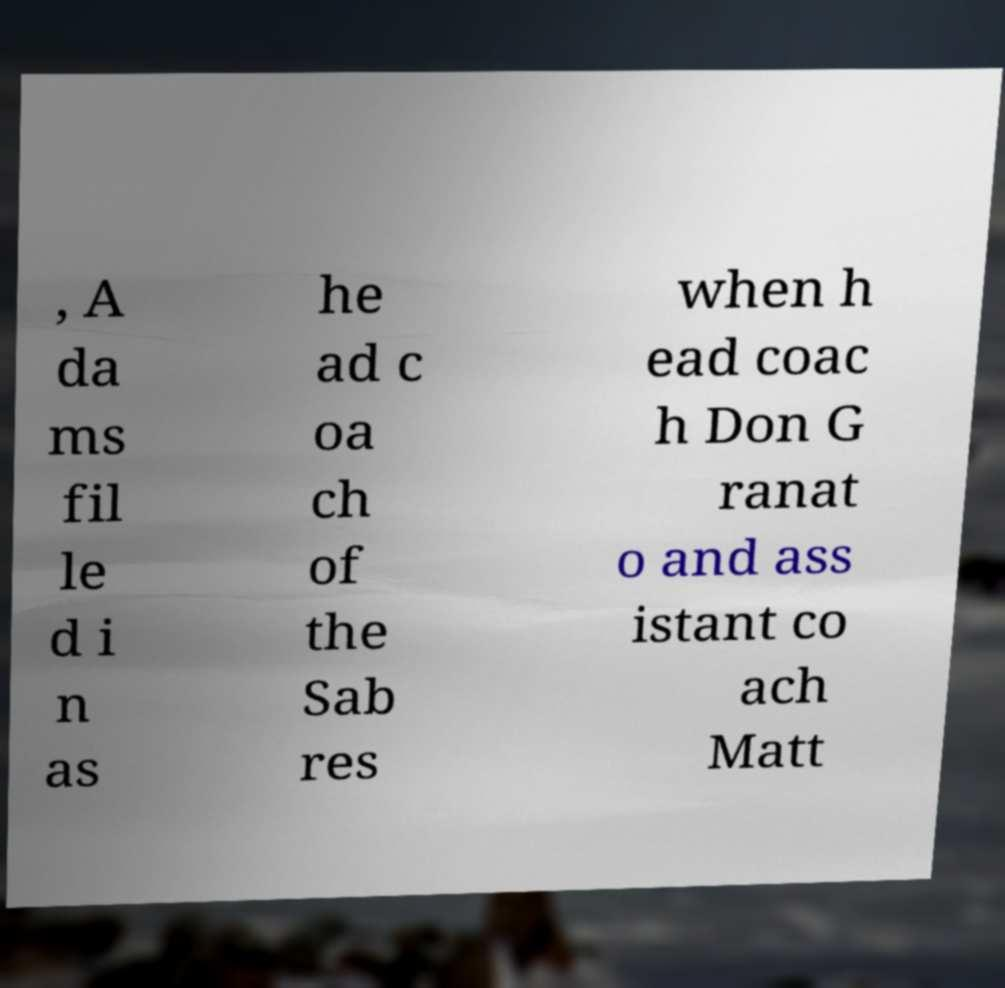What messages or text are displayed in this image? I need them in a readable, typed format. , A da ms fil le d i n as he ad c oa ch of the Sab res when h ead coac h Don G ranat o and ass istant co ach Matt 